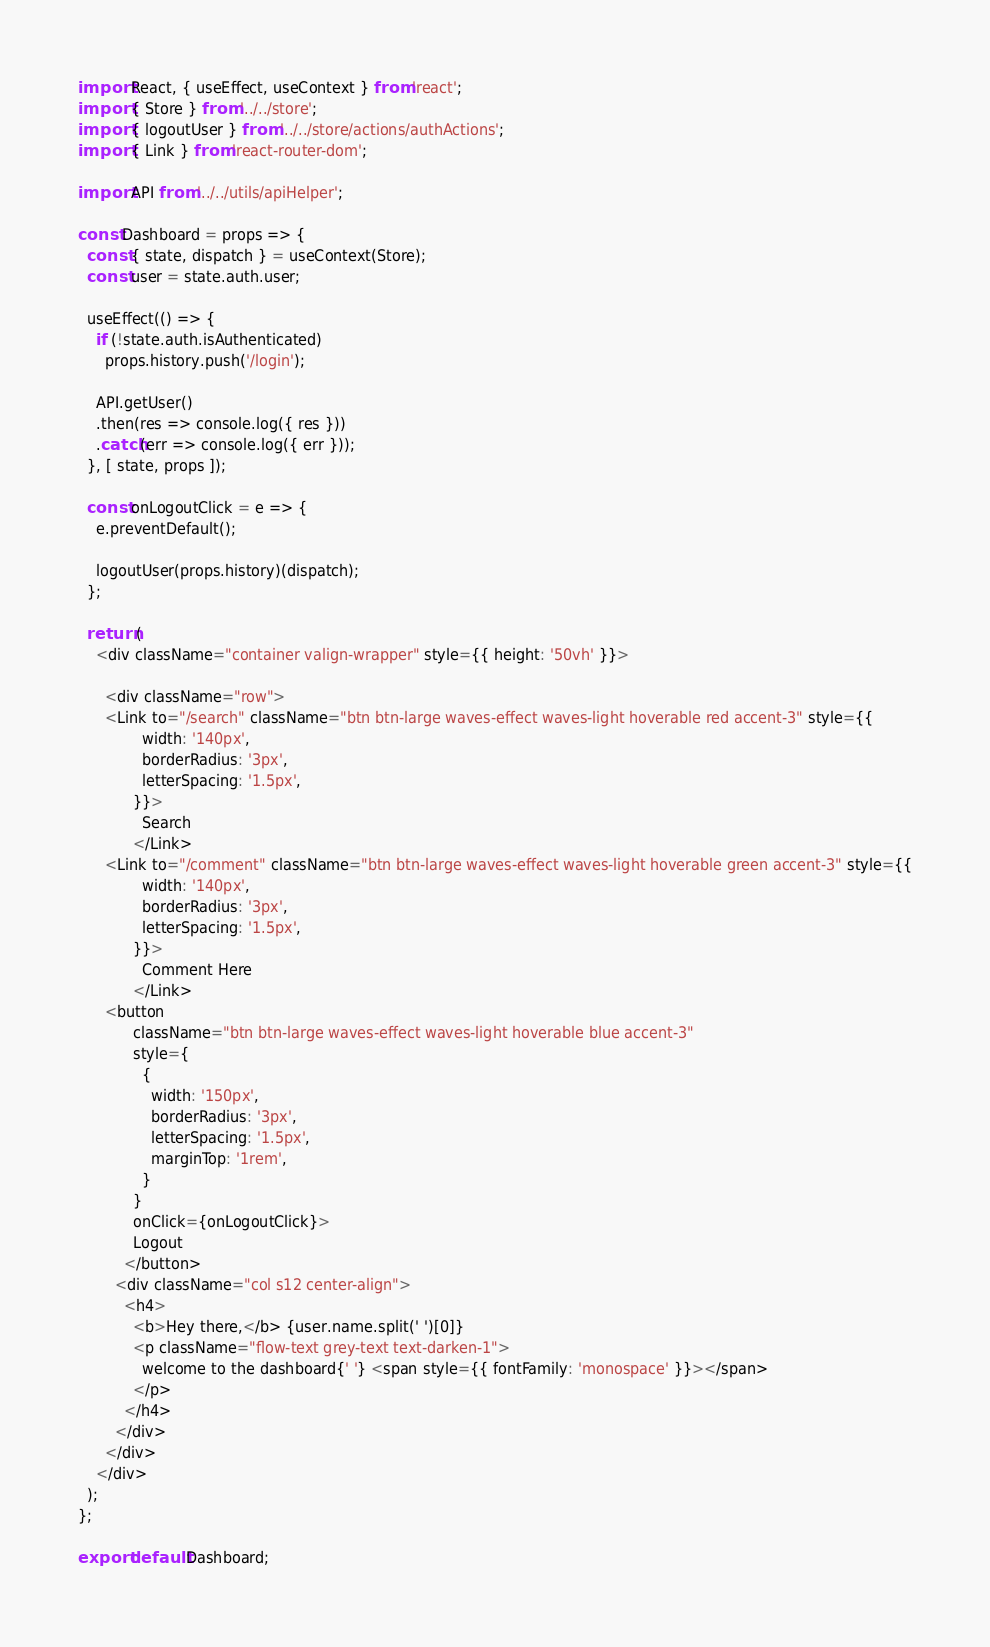Convert code to text. <code><loc_0><loc_0><loc_500><loc_500><_JavaScript_>import React, { useEffect, useContext } from 'react';
import { Store } from '../../store';
import { logoutUser } from '../../store/actions/authActions';
import { Link } from 'react-router-dom';

import API from '../../utils/apiHelper';

const Dashboard = props => {
  const { state, dispatch } = useContext(Store);
  const user = state.auth.user;

  useEffect(() => {
    if (!state.auth.isAuthenticated)
      props.history.push('/login');

    API.getUser()
    .then(res => console.log({ res }))
    .catch(err => console.log({ err }));
  }, [ state, props ]);

  const onLogoutClick = e => {
    e.preventDefault();

    logoutUser(props.history)(dispatch);
  };

  return (
    <div className="container valign-wrapper" style={{ height: '50vh' }}>
      
      <div className="row">
      <Link to="/search" className="btn btn-large waves-effect waves-light hoverable red accent-3" style={{
              width: '140px',
              borderRadius: '3px',
              letterSpacing: '1.5px',
            }}>
              Search
            </Link>
      <Link to="/comment" className="btn btn-large waves-effect waves-light hoverable green accent-3" style={{
              width: '140px',
              borderRadius: '3px',
              letterSpacing: '1.5px',
            }}>
              Comment Here
            </Link>
      <button
            className="btn btn-large waves-effect waves-light hoverable blue accent-3"
            style={
              {
                width: '150px',
                borderRadius: '3px',
                letterSpacing: '1.5px',
                marginTop: '1rem',
              }
            }
            onClick={onLogoutClick}>
            Logout
          </button>
        <div className="col s12 center-align">
          <h4>
            <b>Hey there,</b> {user.name.split(' ')[0]}
            <p className="flow-text grey-text text-darken-1">
              welcome to the dashboard{' '} <span style={{ fontFamily: 'monospace' }}></span>
            </p>
          </h4>
        </div>
      </div>
    </div>
  );
};

export default Dashboard;
</code> 